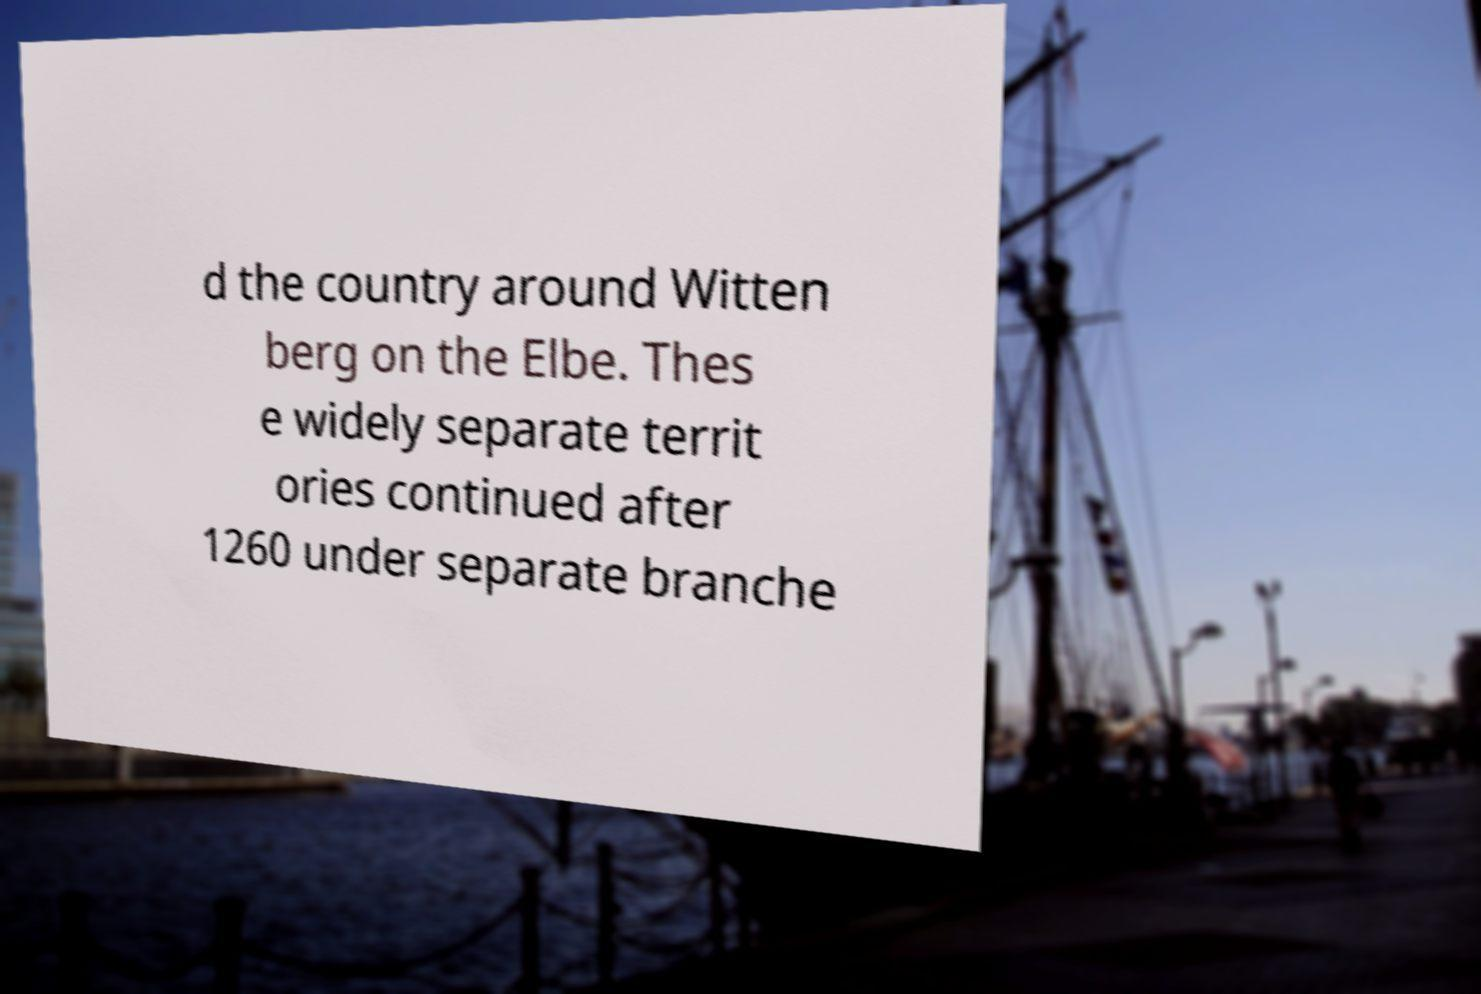Can you accurately transcribe the text from the provided image for me? d the country around Witten berg on the Elbe. Thes e widely separate territ ories continued after 1260 under separate branche 